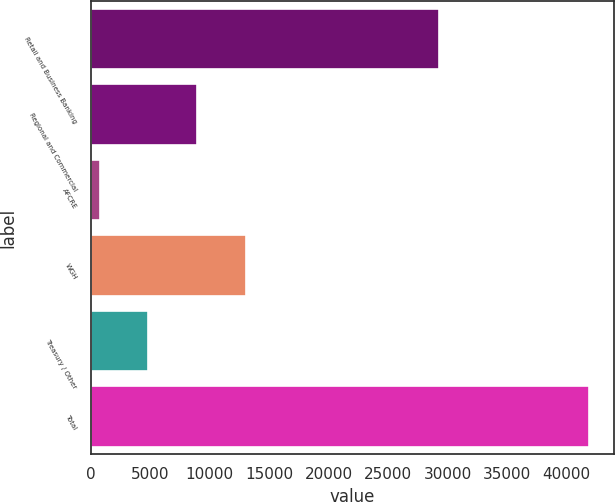Convert chart to OTSL. <chart><loc_0><loc_0><loc_500><loc_500><bar_chart><fcel>Retail and Business Banking<fcel>Regional and Commercial<fcel>AFCRE<fcel>WGH<fcel>Treasury / Other<fcel>Total<nl><fcel>29298<fcel>8973.2<fcel>753<fcel>13083.3<fcel>4863.1<fcel>41854<nl></chart> 